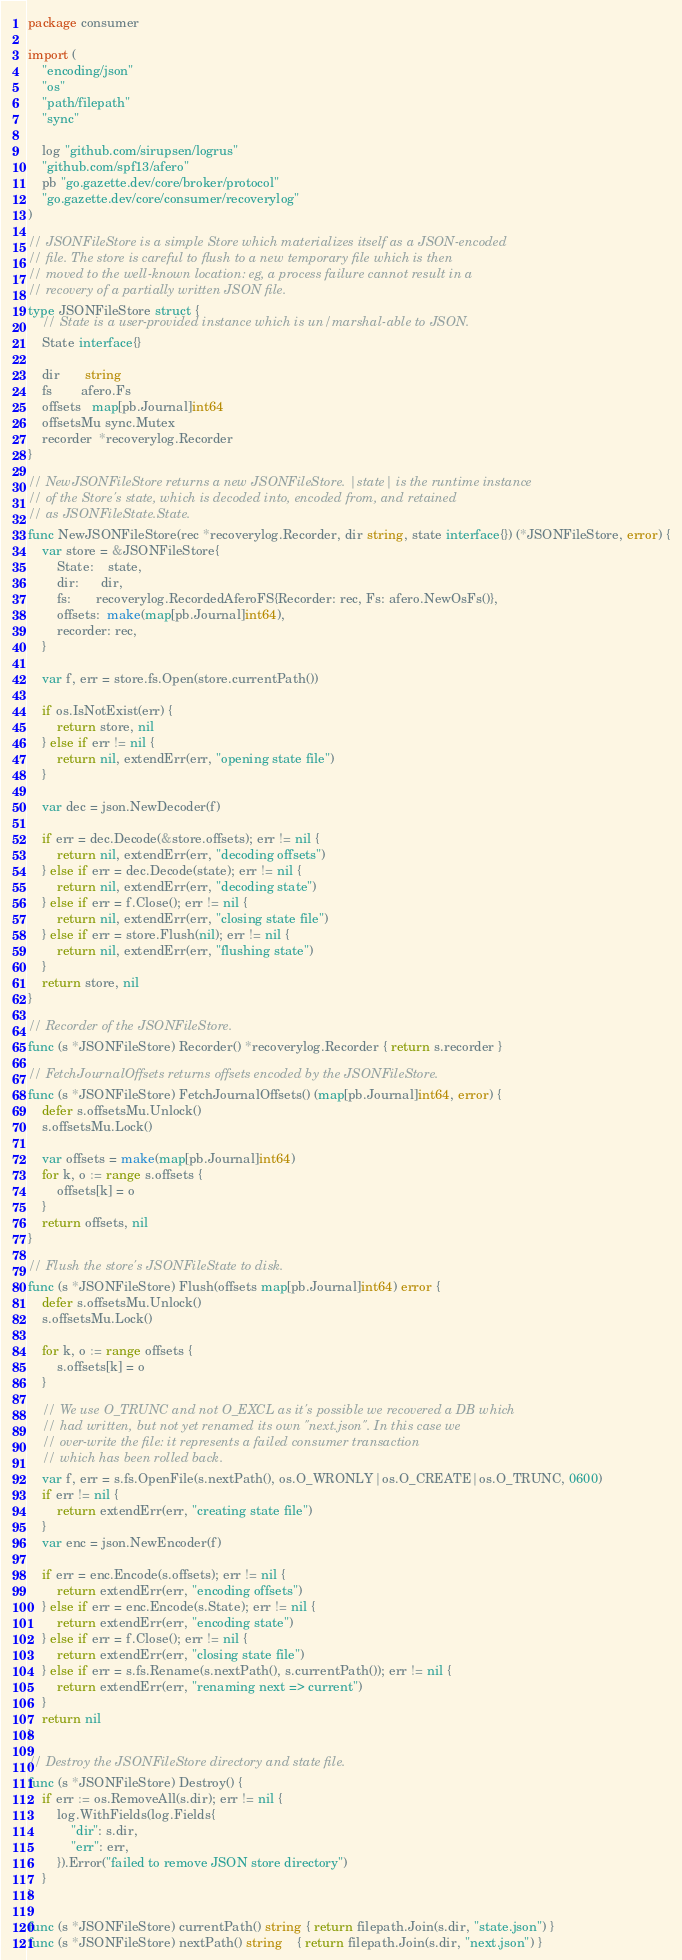Convert code to text. <code><loc_0><loc_0><loc_500><loc_500><_Go_>package consumer

import (
	"encoding/json"
	"os"
	"path/filepath"
	"sync"

	log "github.com/sirupsen/logrus"
	"github.com/spf13/afero"
	pb "go.gazette.dev/core/broker/protocol"
	"go.gazette.dev/core/consumer/recoverylog"
)

// JSONFileStore is a simple Store which materializes itself as a JSON-encoded
// file. The store is careful to flush to a new temporary file which is then
// moved to the well-known location: eg, a process failure cannot result in a
// recovery of a partially written JSON file.
type JSONFileStore struct {
	// State is a user-provided instance which is un/marshal-able to JSON.
	State interface{}

	dir       string
	fs        afero.Fs
	offsets   map[pb.Journal]int64
	offsetsMu sync.Mutex
	recorder  *recoverylog.Recorder
}

// NewJSONFileStore returns a new JSONFileStore. |state| is the runtime instance
// of the Store's state, which is decoded into, encoded from, and retained
// as JSONFileState.State.
func NewJSONFileStore(rec *recoverylog.Recorder, dir string, state interface{}) (*JSONFileStore, error) {
	var store = &JSONFileStore{
		State:    state,
		dir:      dir,
		fs:       recoverylog.RecordedAferoFS{Recorder: rec, Fs: afero.NewOsFs()},
		offsets:  make(map[pb.Journal]int64),
		recorder: rec,
	}

	var f, err = store.fs.Open(store.currentPath())

	if os.IsNotExist(err) {
		return store, nil
	} else if err != nil {
		return nil, extendErr(err, "opening state file")
	}

	var dec = json.NewDecoder(f)

	if err = dec.Decode(&store.offsets); err != nil {
		return nil, extendErr(err, "decoding offsets")
	} else if err = dec.Decode(state); err != nil {
		return nil, extendErr(err, "decoding state")
	} else if err = f.Close(); err != nil {
		return nil, extendErr(err, "closing state file")
	} else if err = store.Flush(nil); err != nil {
		return nil, extendErr(err, "flushing state")
	}
	return store, nil
}

// Recorder of the JSONFileStore.
func (s *JSONFileStore) Recorder() *recoverylog.Recorder { return s.recorder }

// FetchJournalOffsets returns offsets encoded by the JSONFileStore.
func (s *JSONFileStore) FetchJournalOffsets() (map[pb.Journal]int64, error) {
	defer s.offsetsMu.Unlock()
	s.offsetsMu.Lock()

	var offsets = make(map[pb.Journal]int64)
	for k, o := range s.offsets {
		offsets[k] = o
	}
	return offsets, nil
}

// Flush the store's JSONFileState to disk.
func (s *JSONFileStore) Flush(offsets map[pb.Journal]int64) error {
	defer s.offsetsMu.Unlock()
	s.offsetsMu.Lock()

	for k, o := range offsets {
		s.offsets[k] = o
	}

	// We use O_TRUNC and not O_EXCL as it's possible we recovered a DB which
	// had written, but not yet renamed its own "next.json". In this case we
	// over-write the file: it represents a failed consumer transaction
	// which has been rolled back.
	var f, err = s.fs.OpenFile(s.nextPath(), os.O_WRONLY|os.O_CREATE|os.O_TRUNC, 0600)
	if err != nil {
		return extendErr(err, "creating state file")
	}
	var enc = json.NewEncoder(f)

	if err = enc.Encode(s.offsets); err != nil {
		return extendErr(err, "encoding offsets")
	} else if err = enc.Encode(s.State); err != nil {
		return extendErr(err, "encoding state")
	} else if err = f.Close(); err != nil {
		return extendErr(err, "closing state file")
	} else if err = s.fs.Rename(s.nextPath(), s.currentPath()); err != nil {
		return extendErr(err, "renaming next => current")
	}
	return nil
}

// Destroy the JSONFileStore directory and state file.
func (s *JSONFileStore) Destroy() {
	if err := os.RemoveAll(s.dir); err != nil {
		log.WithFields(log.Fields{
			"dir": s.dir,
			"err": err,
		}).Error("failed to remove JSON store directory")
	}
}

func (s *JSONFileStore) currentPath() string { return filepath.Join(s.dir, "state.json") }
func (s *JSONFileStore) nextPath() string    { return filepath.Join(s.dir, "next.json") }
</code> 